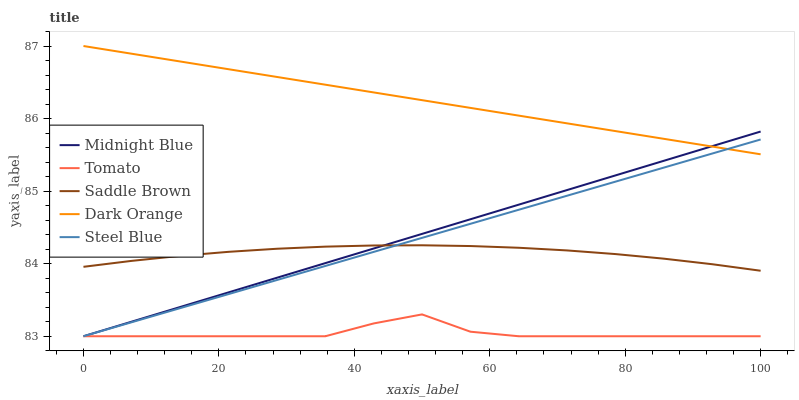Does Steel Blue have the minimum area under the curve?
Answer yes or no. No. Does Steel Blue have the maximum area under the curve?
Answer yes or no. No. Is Steel Blue the smoothest?
Answer yes or no. No. Is Steel Blue the roughest?
Answer yes or no. No. Does Dark Orange have the lowest value?
Answer yes or no. No. Does Steel Blue have the highest value?
Answer yes or no. No. Is Tomato less than Saddle Brown?
Answer yes or no. Yes. Is Saddle Brown greater than Tomato?
Answer yes or no. Yes. Does Tomato intersect Saddle Brown?
Answer yes or no. No. 